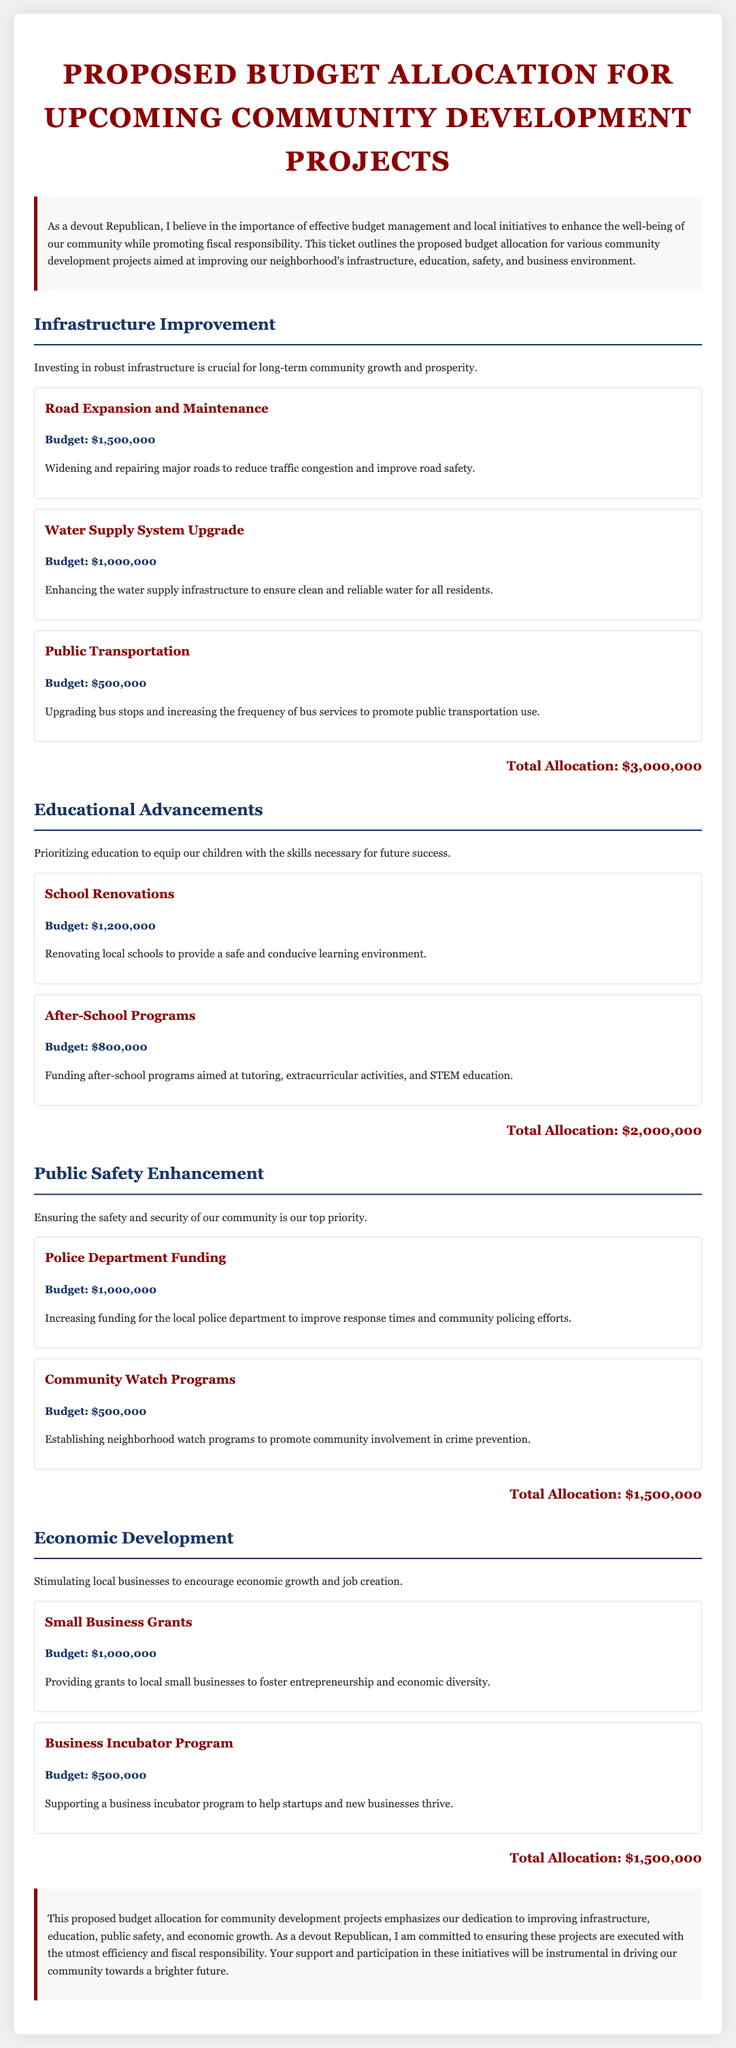What is the total budget allocation for Infrastructure Improvement? The total budget allocation for Infrastructure Improvement is detailed under that section, summing up to $3,000,000.
Answer: $3,000,000 What project has the highest budget in Educational Advancements? The project with the highest budget in Educational Advancements is the School Renovations, budgeted at $1,200,000.
Answer: School Renovations How much is being allocated for Police Department Funding? The allocation for Police Department Funding is clearly stated in the document as $1,000,000.
Answer: $1,000,000 What are the total allocations for Economic Development projects? The total allocations for Economic Development projects can be summed from its sub-project contributions, which equal $1,500,000.
Answer: $1,500,000 What is the budget for the Water Supply System Upgrade? The budget for the Water Supply System Upgrade is specified as $1,000,000.
Answer: $1,000,000 Which section emphasizes public safety? The section that emphasizes public safety is titled "Public Safety Enhancement."
Answer: Public Safety Enhancement What is the budget for After-School Programs? The budget for After-School Programs is stated as $800,000.
Answer: $800,000 Which project is listed under Infrastructure Improvement that aims to reduce traffic congestion? The project aimed at reducing traffic congestion is the Road Expansion and Maintenance.
Answer: Road Expansion and Maintenance What is the main priority outlined in the conclusion? The main priority outlined in the conclusion is improving infrastructure, education, public safety, and economic growth.
Answer: Improving infrastructure, education, public safety, and economic growth 